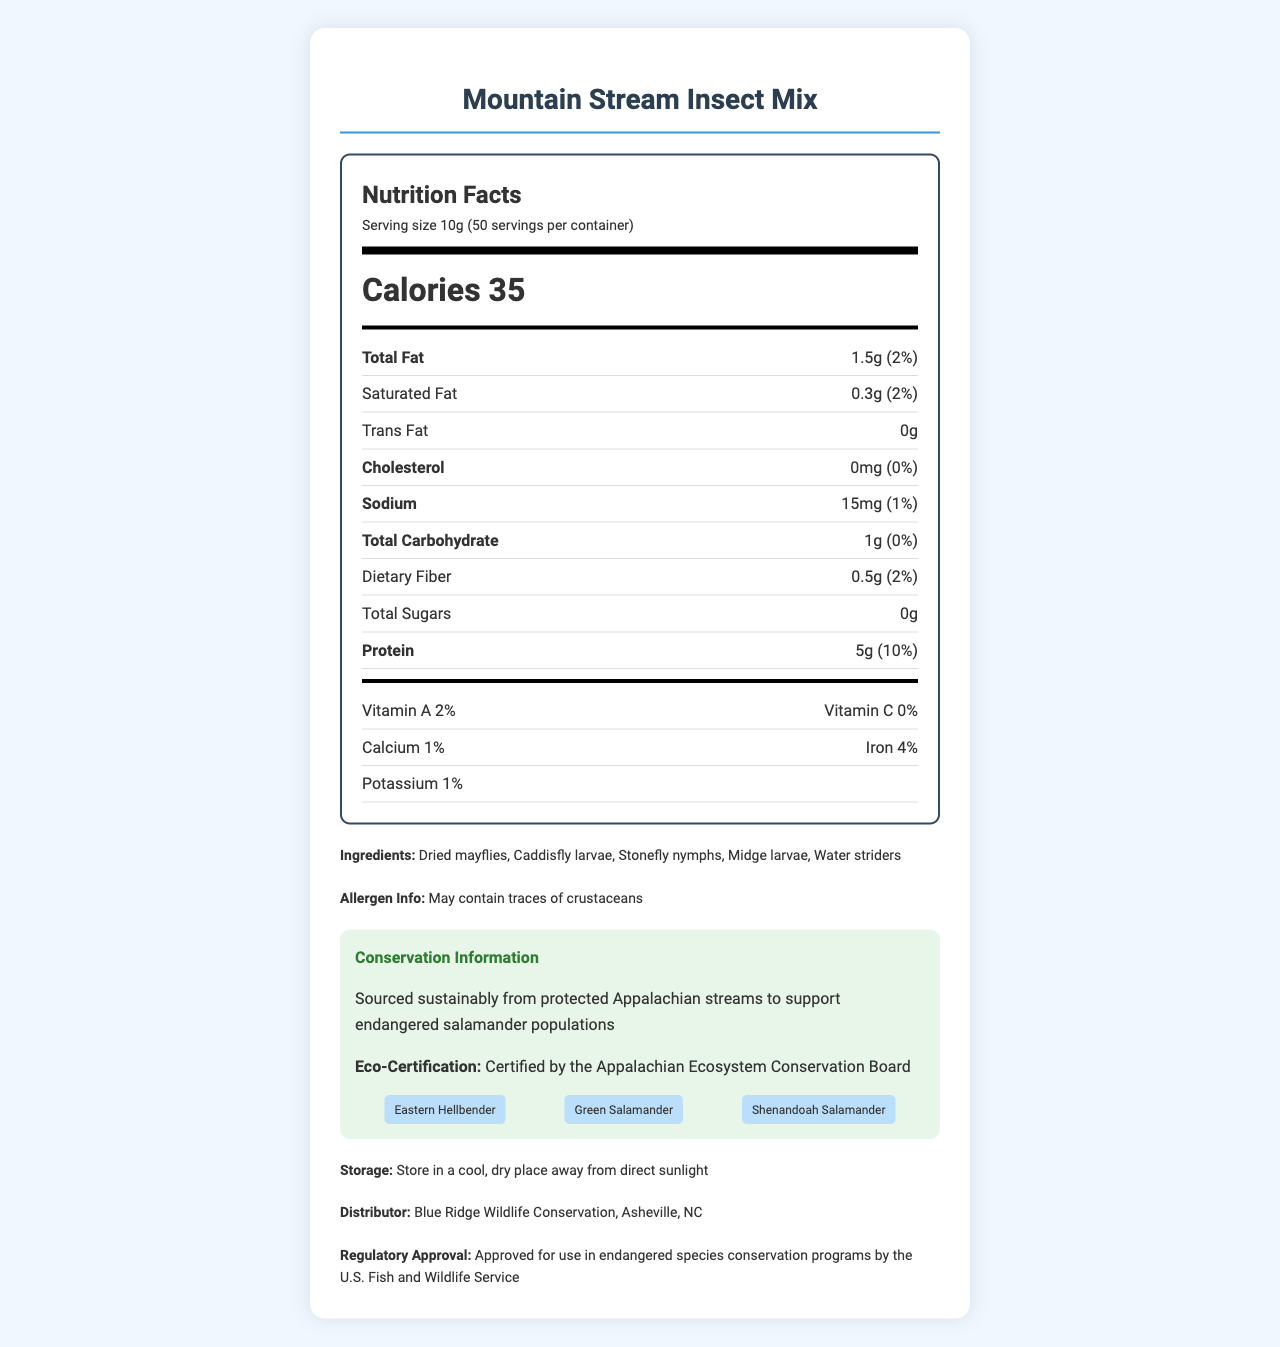what is the serving size? The document states that the serving size is 10g.
Answer: 10g how many calories are in one serving? The document specifies that there are 35 calories per serving.
Answer: 35 calories what are the main ingredients in the product? The ingredients listed in the document are: Dried mayflies, Caddisfly larvae, Stonefly nymphs, Midge larvae, Water striders.
Answer: Dried mayflies, Caddisfly larvae, Stonefly nymphs, Midge larvae, Water striders what is the daily value percentage of protein? The document mentions that the protein content provides 10% of the daily value.
Answer: 10% where should the product be stored? The storage instructions in the document indicate that the product should be kept in a cool, dry place away from direct sunlight.
Answer: In a cool, dry place away from direct sunlight which nutrient has the highest daily value percentage? A. Iron B. Protein C. Vitamin A D. Sodium Protein has the highest daily value percentage at 10%.
Answer: B which of the following is not a target species of the product? A. Eastern Hellbender B. Green Salamander C. Shenandoah Salamander D. Appalachian Forest Turtle The document lists Eastern Hellbender, Green Salamander, and Shenandoah Salamander as target species, but not the Appalachian Forest Turtle.
Answer: D is this product certified by a conservation board? The document states that the product is certified by the Appalachian Ecosystem Conservation Board.
Answer: Yes does the product contain any saturated fat? The document mentions that the product contains 0.3g of saturated fat (2% daily value).
Answer: Yes summarize the main idea of the document. The document aims to inform about the "Mountain Stream Insect Mix," including its nutritional information, ingredients, conservation certifications, target species, and storage instructions, emphasizing its sustainable and regulatory-compliant nature.
Answer: The document provides the nutrition facts, ingredients, and other details for the "Mountain Stream Insect Mix," a food product for endangered Appalachian salamanders. It highlights the nutritional content, sustainable sourcing, and target species, with approval from relevant regulatory bodies. what is the percentage of calcium in the product? The document lists that the calcium content is 1%.
Answer: 1% what is the regulatory approval information? The document states that the product is approved for use in endangered species conservation programs by the U.S. Fish and Wildlife Service.
Answer: Approved for use in endangered species conservation programs by the U.S. Fish and Wildlife Service how many servings are in the container? The document mentions that there are 50 servings per container.
Answer: 50 how much sodium does each serving contain? Each serving contains 15mg of sodium as per the document.
Answer: 15mg what is the origin of the insects used in the product? The document states that the insects are sourced sustainably from protected Appalachian streams.
Answer: Sourced sustainably from protected Appalachian streams who is the distributor of the product? The distributor listed in the document is Blue Ridge Wildlife Conservation in Asheville, NC.
Answer: Blue Ridge Wildlife Conservation, Asheville, NC what are the allergen details provided? The allergen information in the document indicates that the product may contain traces of crustaceans.
Answer: May contain traces of crustaceans how much dietary fiber is in one serving? The document mentions that each serving contains 0.5g of dietary fiber.
Answer: 0.5g how many calories does the entire container hold if it has 50 servings? By multiplying the calories per serving (35) by the number of servings (50), the total is 1750 calories.
Answer: 1750 calories which vitamins are mentioned in the product? A. Vitamin A and Vitamin B B. Vitamin A and Vitamin C C. Vitamin B and Vitamin C D. Vitamin A and Vitamin D The document mentions Vitamin A (2%) and Vitamin C (0%).
Answer: B how is the insect mix beneficial for conservation efforts? The document specifies that the product supports conservation by using sustainably sourced insects from protected Appalachian streams, aiding endangered salamander populations.
Answer: The product is sourced sustainably from protected Appalachian streams to support endangered salamander populations. what species are targeted by the Mountain Stream Insect Mix? The document states that the target species for the product are Eastern Hellbender, Green Salamander, and Shenandoah Salamander.
Answer: Eastern Hellbender, Green Salamander, Shenandoah Salamander does the product contain cholesterol? The document states that the product contains 0mg of cholesterol, which is 0% of the daily value.
Answer: No what is the amount of total sugars in the product? The document mentions that the product contains 0g of total sugars.
Answer: 0g what are the potential benefits for endangered salamanders consuming this mix? The document does not detail the specific benefits for the salamanders apart from the general conservation statement.
Answer: Not enough information 